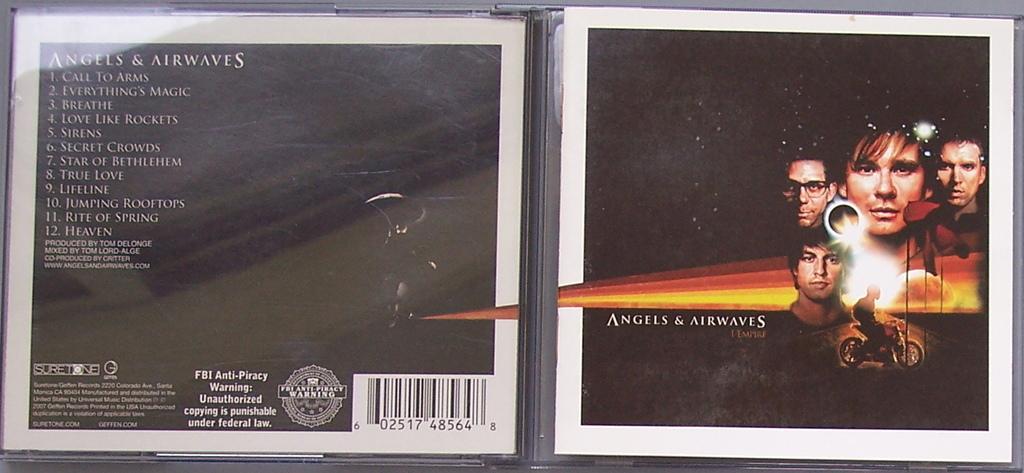What is the title of this album?
Offer a very short reply. Angels & airwaves. 